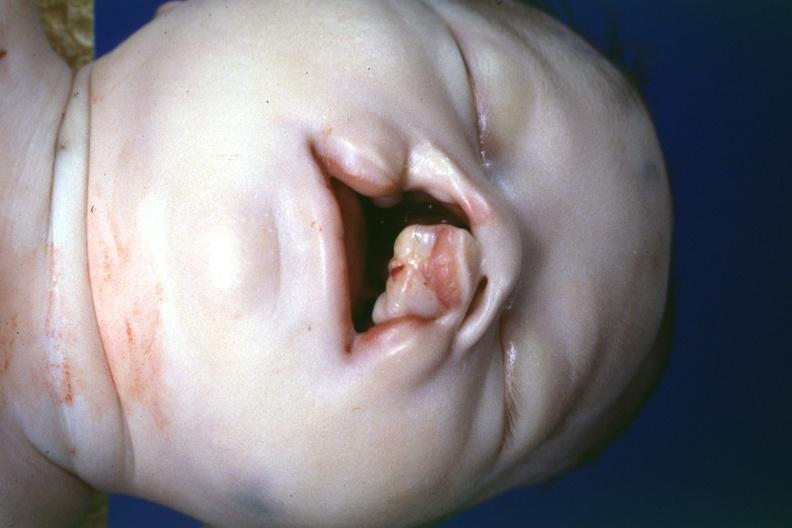s nodule present?
Answer the question using a single word or phrase. No 